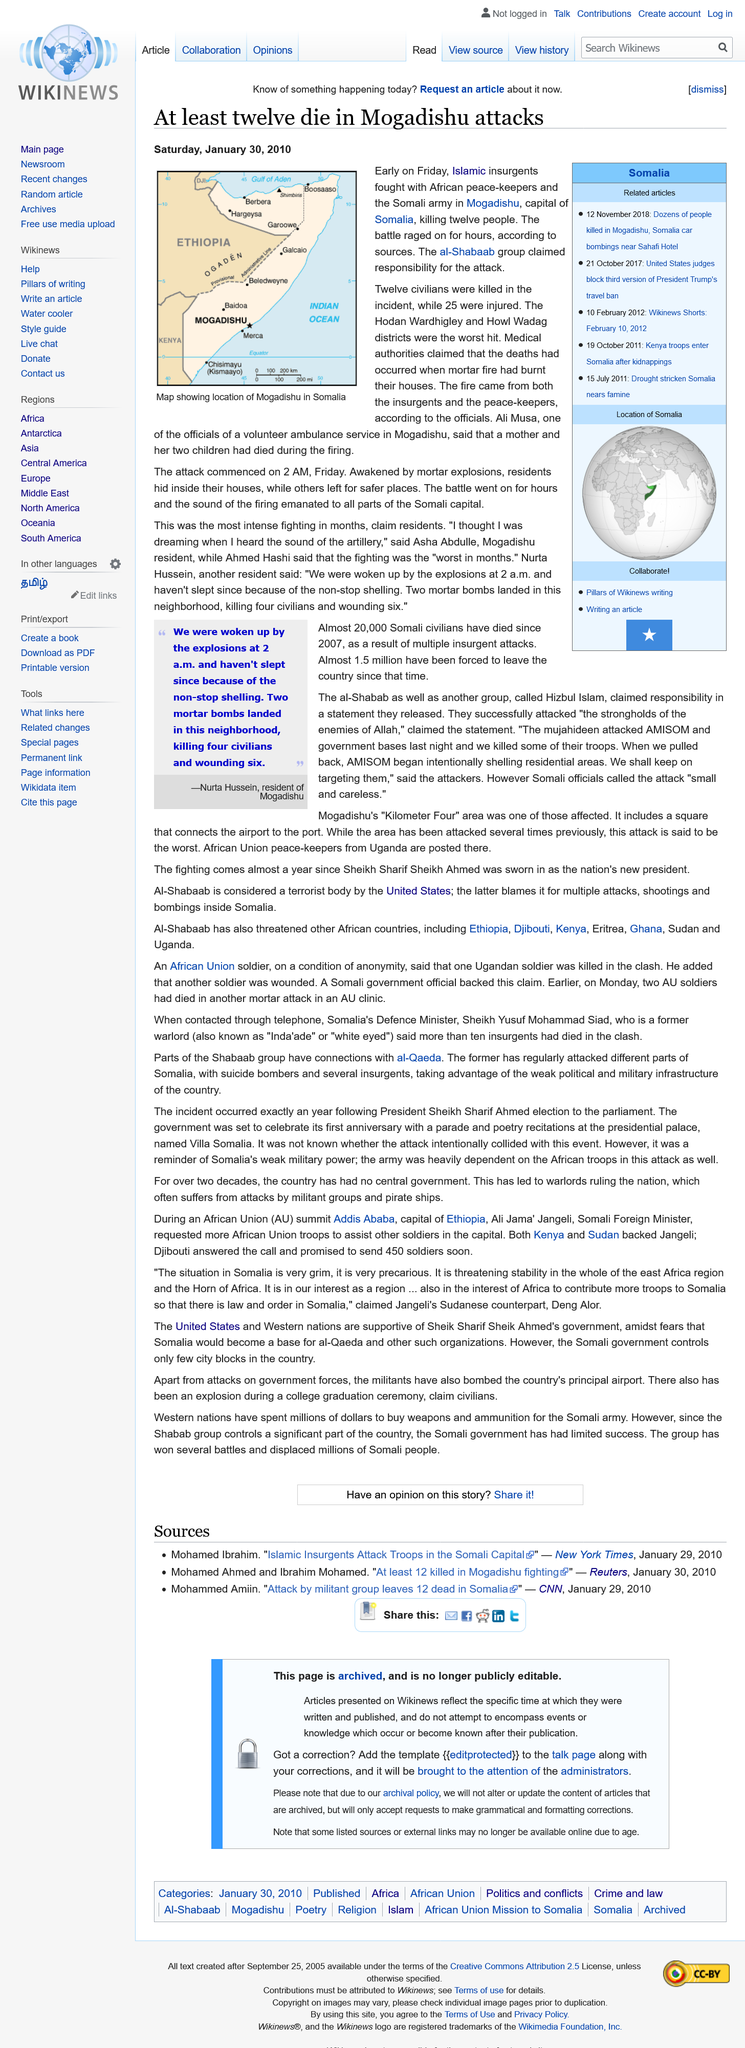Draw attention to some important aspects in this diagram. Mogadishu, the capital of Somalia, is located in a country known for its rich cultural heritage and stunning natural beauty. Twelve civilians were killed when Islamic insurgents clashed with African peace-keepers in an incident that involved civilian casualties. During the conflict between Islamic insurgents and African peacekeepers, the Hodan Wardhigley and Howl Wadag districts were the worst hit. 